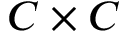<formula> <loc_0><loc_0><loc_500><loc_500>C \times C</formula> 